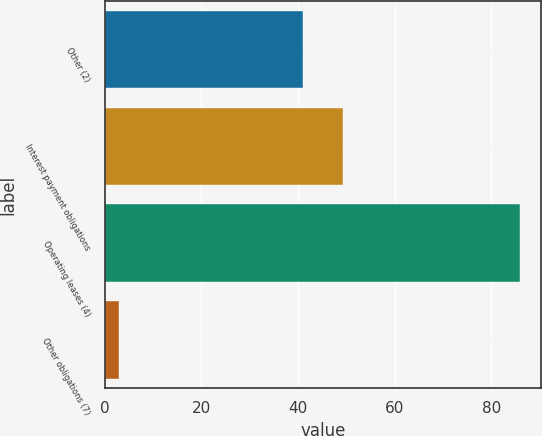<chart> <loc_0><loc_0><loc_500><loc_500><bar_chart><fcel>Other (2)<fcel>Interest payment obligations<fcel>Operating leases (4)<fcel>Other obligations (7)<nl><fcel>41<fcel>49.3<fcel>86<fcel>3<nl></chart> 